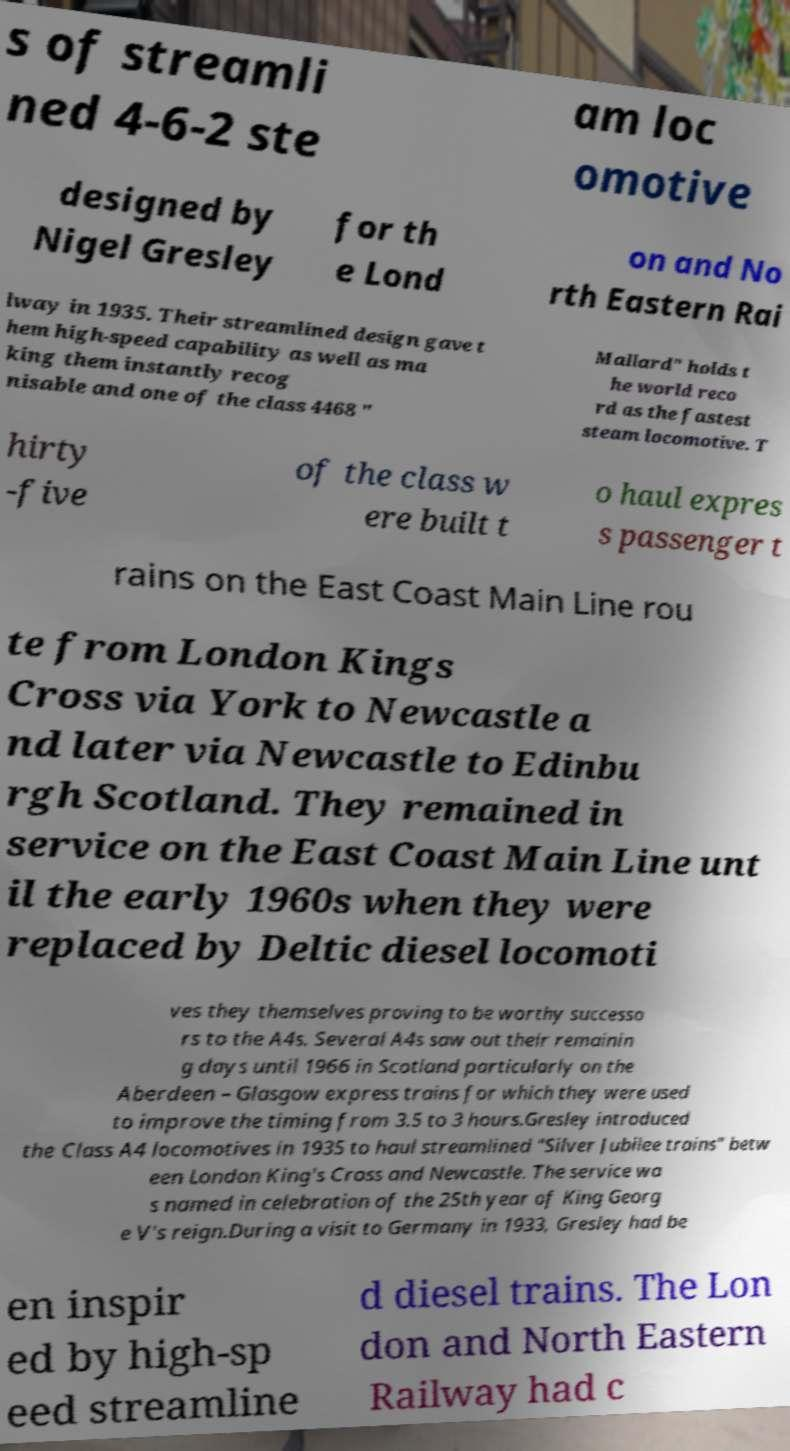Please identify and transcribe the text found in this image. s of streamli ned 4-6-2 ste am loc omotive designed by Nigel Gresley for th e Lond on and No rth Eastern Rai lway in 1935. Their streamlined design gave t hem high-speed capability as well as ma king them instantly recog nisable and one of the class 4468 " Mallard" holds t he world reco rd as the fastest steam locomotive. T hirty -five of the class w ere built t o haul expres s passenger t rains on the East Coast Main Line rou te from London Kings Cross via York to Newcastle a nd later via Newcastle to Edinbu rgh Scotland. They remained in service on the East Coast Main Line unt il the early 1960s when they were replaced by Deltic diesel locomoti ves they themselves proving to be worthy successo rs to the A4s. Several A4s saw out their remainin g days until 1966 in Scotland particularly on the Aberdeen – Glasgow express trains for which they were used to improve the timing from 3.5 to 3 hours.Gresley introduced the Class A4 locomotives in 1935 to haul streamlined "Silver Jubilee trains" betw een London King's Cross and Newcastle. The service wa s named in celebration of the 25th year of King Georg e V's reign.During a visit to Germany in 1933, Gresley had be en inspir ed by high-sp eed streamline d diesel trains. The Lon don and North Eastern Railway had c 